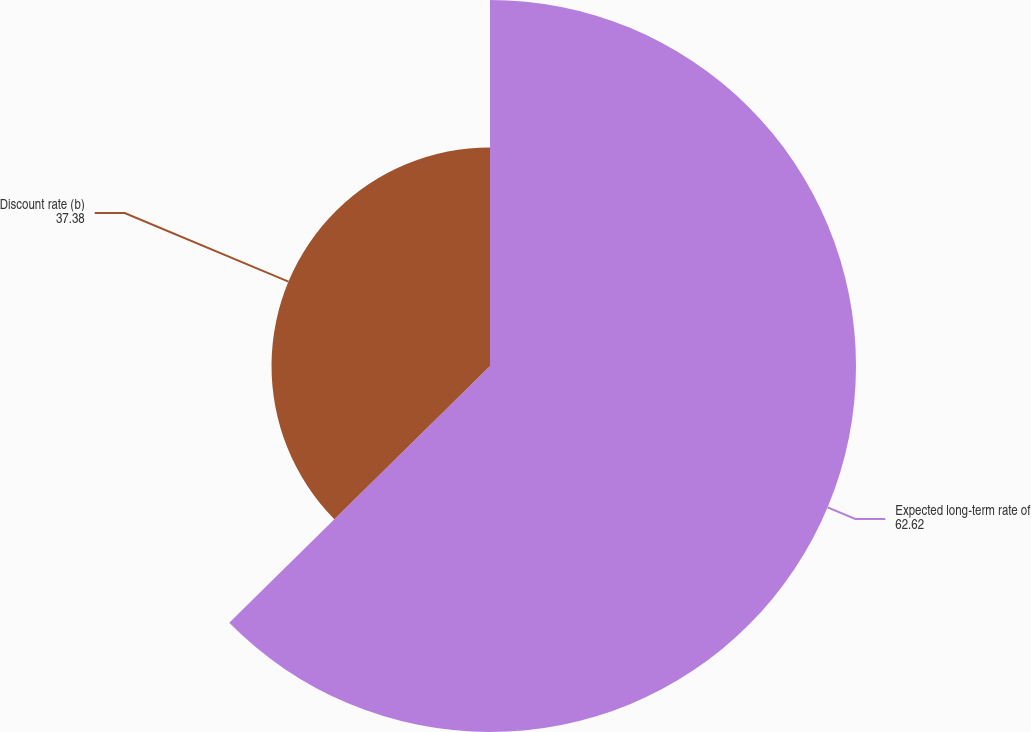<chart> <loc_0><loc_0><loc_500><loc_500><pie_chart><fcel>Expected long-term rate of<fcel>Discount rate (b)<nl><fcel>62.62%<fcel>37.38%<nl></chart> 